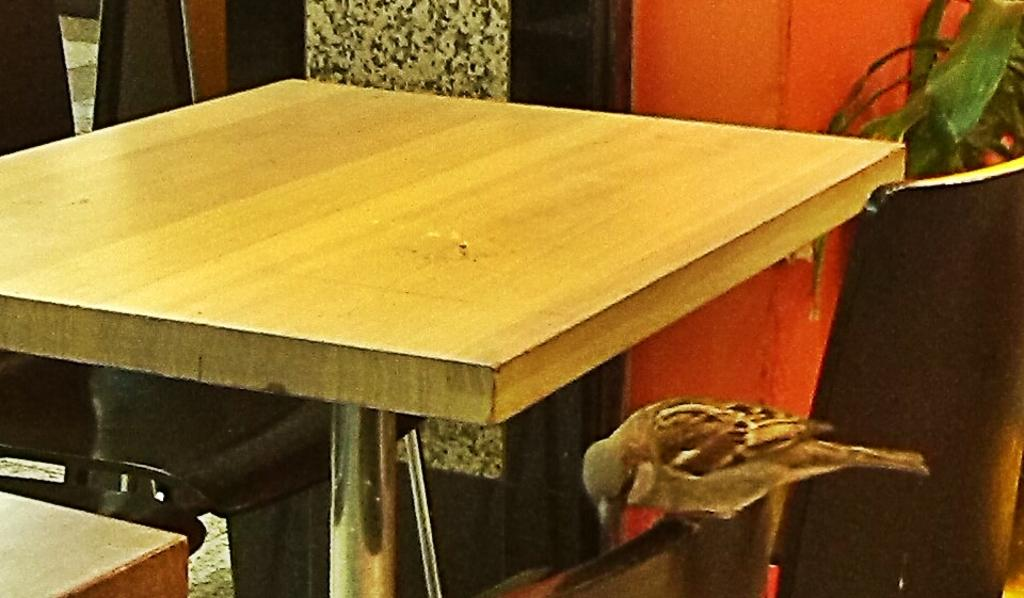What is the main object in the center of the image? There is a table in the middle of the image. Where is the bird located in the image? The bird is in the right side corner of the image. What can be seen at the top of the image? There is a plant in the top of the image. What type of fang can be seen in the image? There is no fang present in the image. Are there any dinosaurs visible in the image? There are no dinosaurs present in the image. 